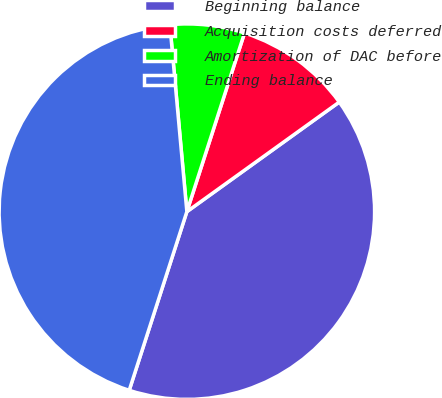Convert chart to OTSL. <chart><loc_0><loc_0><loc_500><loc_500><pie_chart><fcel>Beginning balance<fcel>Acquisition costs deferred<fcel>Amortization of DAC before<fcel>Ending balance<nl><fcel>39.89%<fcel>10.11%<fcel>6.41%<fcel>43.59%<nl></chart> 